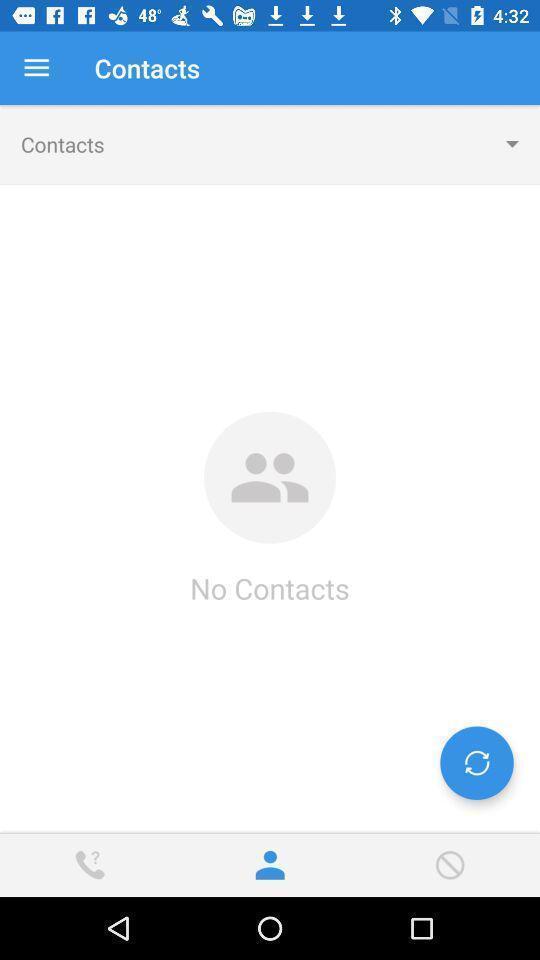What can you discern from this picture? Screen showing a blank screen in contacts page. 